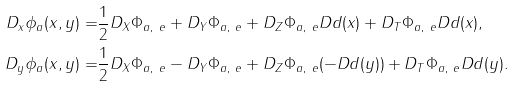Convert formula to latex. <formula><loc_0><loc_0><loc_500><loc_500>D _ { x } \phi _ { a } ( x , y ) = & \frac { 1 } { 2 } D _ { X } \Phi _ { a , \ e } + D _ { Y } \Phi _ { a , \ e } + D _ { Z } \Phi _ { a , \ e } D d ( x ) + D _ { T } \Phi _ { a , \ e } D d ( x ) , \\ D _ { y } \phi _ { a } ( x , y ) = & \frac { 1 } { 2 } D _ { X } \Phi _ { a , \ e } - D _ { Y } \Phi _ { a , \ e } + D _ { Z } \Phi _ { a , \ e } ( - D d ( y ) ) + D _ { T } \Phi _ { a , \ e } D d ( y ) .</formula> 